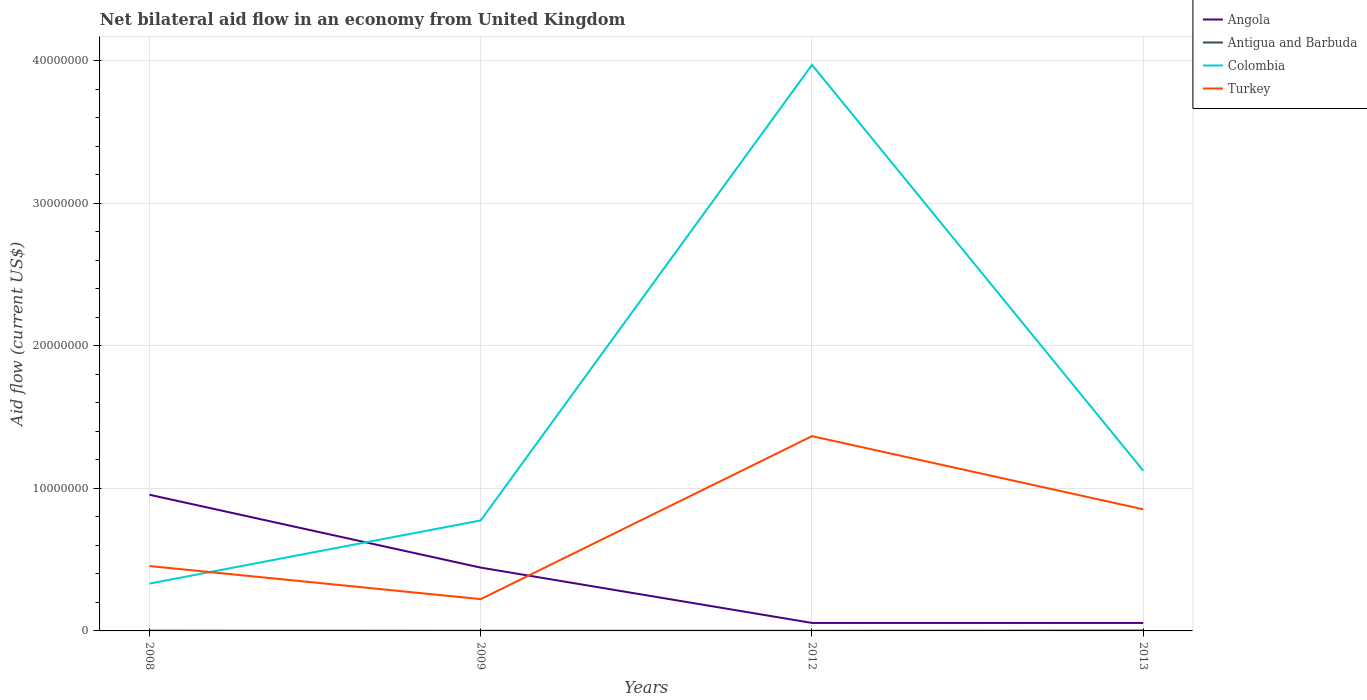In which year was the net bilateral aid flow in Antigua and Barbuda maximum?
Your answer should be very brief. 2009. What is the total net bilateral aid flow in Colombia in the graph?
Offer a terse response. -3.64e+07. What is the difference between the highest and the second highest net bilateral aid flow in Turkey?
Your response must be concise. 1.14e+07. How many lines are there?
Offer a very short reply. 4. How many years are there in the graph?
Provide a short and direct response. 4. What is the difference between two consecutive major ticks on the Y-axis?
Provide a short and direct response. 1.00e+07. Are the values on the major ticks of Y-axis written in scientific E-notation?
Offer a very short reply. No. Does the graph contain grids?
Keep it short and to the point. Yes. How are the legend labels stacked?
Offer a terse response. Vertical. What is the title of the graph?
Offer a terse response. Net bilateral aid flow in an economy from United Kingdom. Does "Djibouti" appear as one of the legend labels in the graph?
Give a very brief answer. No. What is the Aid flow (current US$) in Angola in 2008?
Your answer should be very brief. 9.55e+06. What is the Aid flow (current US$) in Antigua and Barbuda in 2008?
Ensure brevity in your answer.  2.00e+04. What is the Aid flow (current US$) in Colombia in 2008?
Your answer should be compact. 3.32e+06. What is the Aid flow (current US$) in Turkey in 2008?
Provide a succinct answer. 4.55e+06. What is the Aid flow (current US$) in Angola in 2009?
Provide a succinct answer. 4.44e+06. What is the Aid flow (current US$) in Antigua and Barbuda in 2009?
Make the answer very short. 10000. What is the Aid flow (current US$) in Colombia in 2009?
Provide a succinct answer. 7.75e+06. What is the Aid flow (current US$) of Turkey in 2009?
Your answer should be very brief. 2.23e+06. What is the Aid flow (current US$) in Angola in 2012?
Provide a succinct answer. 5.60e+05. What is the Aid flow (current US$) in Antigua and Barbuda in 2012?
Keep it short and to the point. 10000. What is the Aid flow (current US$) in Colombia in 2012?
Make the answer very short. 3.97e+07. What is the Aid flow (current US$) in Turkey in 2012?
Provide a succinct answer. 1.37e+07. What is the Aid flow (current US$) in Angola in 2013?
Keep it short and to the point. 5.60e+05. What is the Aid flow (current US$) of Colombia in 2013?
Offer a terse response. 1.12e+07. What is the Aid flow (current US$) in Turkey in 2013?
Provide a short and direct response. 8.53e+06. Across all years, what is the maximum Aid flow (current US$) of Angola?
Provide a short and direct response. 9.55e+06. Across all years, what is the maximum Aid flow (current US$) in Antigua and Barbuda?
Offer a terse response. 3.00e+04. Across all years, what is the maximum Aid flow (current US$) in Colombia?
Ensure brevity in your answer.  3.97e+07. Across all years, what is the maximum Aid flow (current US$) in Turkey?
Offer a terse response. 1.37e+07. Across all years, what is the minimum Aid flow (current US$) of Angola?
Your answer should be compact. 5.60e+05. Across all years, what is the minimum Aid flow (current US$) of Colombia?
Your response must be concise. 3.32e+06. Across all years, what is the minimum Aid flow (current US$) in Turkey?
Your answer should be compact. 2.23e+06. What is the total Aid flow (current US$) of Angola in the graph?
Your answer should be compact. 1.51e+07. What is the total Aid flow (current US$) of Colombia in the graph?
Your answer should be very brief. 6.20e+07. What is the total Aid flow (current US$) of Turkey in the graph?
Ensure brevity in your answer.  2.90e+07. What is the difference between the Aid flow (current US$) in Angola in 2008 and that in 2009?
Keep it short and to the point. 5.11e+06. What is the difference between the Aid flow (current US$) of Antigua and Barbuda in 2008 and that in 2009?
Your response must be concise. 10000. What is the difference between the Aid flow (current US$) of Colombia in 2008 and that in 2009?
Make the answer very short. -4.43e+06. What is the difference between the Aid flow (current US$) in Turkey in 2008 and that in 2009?
Provide a short and direct response. 2.32e+06. What is the difference between the Aid flow (current US$) of Angola in 2008 and that in 2012?
Keep it short and to the point. 8.99e+06. What is the difference between the Aid flow (current US$) in Colombia in 2008 and that in 2012?
Offer a terse response. -3.64e+07. What is the difference between the Aid flow (current US$) of Turkey in 2008 and that in 2012?
Give a very brief answer. -9.11e+06. What is the difference between the Aid flow (current US$) in Angola in 2008 and that in 2013?
Your response must be concise. 8.99e+06. What is the difference between the Aid flow (current US$) in Colombia in 2008 and that in 2013?
Give a very brief answer. -7.92e+06. What is the difference between the Aid flow (current US$) in Turkey in 2008 and that in 2013?
Your answer should be very brief. -3.98e+06. What is the difference between the Aid flow (current US$) of Angola in 2009 and that in 2012?
Provide a short and direct response. 3.88e+06. What is the difference between the Aid flow (current US$) of Colombia in 2009 and that in 2012?
Make the answer very short. -3.20e+07. What is the difference between the Aid flow (current US$) of Turkey in 2009 and that in 2012?
Ensure brevity in your answer.  -1.14e+07. What is the difference between the Aid flow (current US$) of Angola in 2009 and that in 2013?
Your answer should be compact. 3.88e+06. What is the difference between the Aid flow (current US$) in Colombia in 2009 and that in 2013?
Offer a terse response. -3.49e+06. What is the difference between the Aid flow (current US$) of Turkey in 2009 and that in 2013?
Provide a short and direct response. -6.30e+06. What is the difference between the Aid flow (current US$) of Angola in 2012 and that in 2013?
Provide a succinct answer. 0. What is the difference between the Aid flow (current US$) of Antigua and Barbuda in 2012 and that in 2013?
Keep it short and to the point. -2.00e+04. What is the difference between the Aid flow (current US$) in Colombia in 2012 and that in 2013?
Keep it short and to the point. 2.85e+07. What is the difference between the Aid flow (current US$) of Turkey in 2012 and that in 2013?
Your response must be concise. 5.13e+06. What is the difference between the Aid flow (current US$) of Angola in 2008 and the Aid flow (current US$) of Antigua and Barbuda in 2009?
Your answer should be very brief. 9.54e+06. What is the difference between the Aid flow (current US$) in Angola in 2008 and the Aid flow (current US$) in Colombia in 2009?
Offer a very short reply. 1.80e+06. What is the difference between the Aid flow (current US$) of Angola in 2008 and the Aid flow (current US$) of Turkey in 2009?
Keep it short and to the point. 7.32e+06. What is the difference between the Aid flow (current US$) of Antigua and Barbuda in 2008 and the Aid flow (current US$) of Colombia in 2009?
Make the answer very short. -7.73e+06. What is the difference between the Aid flow (current US$) of Antigua and Barbuda in 2008 and the Aid flow (current US$) of Turkey in 2009?
Your answer should be compact. -2.21e+06. What is the difference between the Aid flow (current US$) in Colombia in 2008 and the Aid flow (current US$) in Turkey in 2009?
Your response must be concise. 1.09e+06. What is the difference between the Aid flow (current US$) in Angola in 2008 and the Aid flow (current US$) in Antigua and Barbuda in 2012?
Your response must be concise. 9.54e+06. What is the difference between the Aid flow (current US$) in Angola in 2008 and the Aid flow (current US$) in Colombia in 2012?
Provide a succinct answer. -3.02e+07. What is the difference between the Aid flow (current US$) in Angola in 2008 and the Aid flow (current US$) in Turkey in 2012?
Offer a terse response. -4.11e+06. What is the difference between the Aid flow (current US$) in Antigua and Barbuda in 2008 and the Aid flow (current US$) in Colombia in 2012?
Ensure brevity in your answer.  -3.97e+07. What is the difference between the Aid flow (current US$) of Antigua and Barbuda in 2008 and the Aid flow (current US$) of Turkey in 2012?
Make the answer very short. -1.36e+07. What is the difference between the Aid flow (current US$) in Colombia in 2008 and the Aid flow (current US$) in Turkey in 2012?
Provide a succinct answer. -1.03e+07. What is the difference between the Aid flow (current US$) of Angola in 2008 and the Aid flow (current US$) of Antigua and Barbuda in 2013?
Your response must be concise. 9.52e+06. What is the difference between the Aid flow (current US$) in Angola in 2008 and the Aid flow (current US$) in Colombia in 2013?
Your answer should be compact. -1.69e+06. What is the difference between the Aid flow (current US$) of Angola in 2008 and the Aid flow (current US$) of Turkey in 2013?
Offer a terse response. 1.02e+06. What is the difference between the Aid flow (current US$) in Antigua and Barbuda in 2008 and the Aid flow (current US$) in Colombia in 2013?
Keep it short and to the point. -1.12e+07. What is the difference between the Aid flow (current US$) of Antigua and Barbuda in 2008 and the Aid flow (current US$) of Turkey in 2013?
Your answer should be very brief. -8.51e+06. What is the difference between the Aid flow (current US$) of Colombia in 2008 and the Aid flow (current US$) of Turkey in 2013?
Offer a terse response. -5.21e+06. What is the difference between the Aid flow (current US$) of Angola in 2009 and the Aid flow (current US$) of Antigua and Barbuda in 2012?
Your answer should be compact. 4.43e+06. What is the difference between the Aid flow (current US$) of Angola in 2009 and the Aid flow (current US$) of Colombia in 2012?
Offer a very short reply. -3.53e+07. What is the difference between the Aid flow (current US$) in Angola in 2009 and the Aid flow (current US$) in Turkey in 2012?
Make the answer very short. -9.22e+06. What is the difference between the Aid flow (current US$) of Antigua and Barbuda in 2009 and the Aid flow (current US$) of Colombia in 2012?
Provide a succinct answer. -3.97e+07. What is the difference between the Aid flow (current US$) of Antigua and Barbuda in 2009 and the Aid flow (current US$) of Turkey in 2012?
Provide a succinct answer. -1.36e+07. What is the difference between the Aid flow (current US$) in Colombia in 2009 and the Aid flow (current US$) in Turkey in 2012?
Ensure brevity in your answer.  -5.91e+06. What is the difference between the Aid flow (current US$) of Angola in 2009 and the Aid flow (current US$) of Antigua and Barbuda in 2013?
Offer a very short reply. 4.41e+06. What is the difference between the Aid flow (current US$) in Angola in 2009 and the Aid flow (current US$) in Colombia in 2013?
Make the answer very short. -6.80e+06. What is the difference between the Aid flow (current US$) of Angola in 2009 and the Aid flow (current US$) of Turkey in 2013?
Your answer should be compact. -4.09e+06. What is the difference between the Aid flow (current US$) of Antigua and Barbuda in 2009 and the Aid flow (current US$) of Colombia in 2013?
Provide a succinct answer. -1.12e+07. What is the difference between the Aid flow (current US$) of Antigua and Barbuda in 2009 and the Aid flow (current US$) of Turkey in 2013?
Offer a very short reply. -8.52e+06. What is the difference between the Aid flow (current US$) of Colombia in 2009 and the Aid flow (current US$) of Turkey in 2013?
Your response must be concise. -7.80e+05. What is the difference between the Aid flow (current US$) of Angola in 2012 and the Aid flow (current US$) of Antigua and Barbuda in 2013?
Offer a terse response. 5.30e+05. What is the difference between the Aid flow (current US$) in Angola in 2012 and the Aid flow (current US$) in Colombia in 2013?
Provide a short and direct response. -1.07e+07. What is the difference between the Aid flow (current US$) in Angola in 2012 and the Aid flow (current US$) in Turkey in 2013?
Provide a short and direct response. -7.97e+06. What is the difference between the Aid flow (current US$) in Antigua and Barbuda in 2012 and the Aid flow (current US$) in Colombia in 2013?
Your response must be concise. -1.12e+07. What is the difference between the Aid flow (current US$) of Antigua and Barbuda in 2012 and the Aid flow (current US$) of Turkey in 2013?
Your response must be concise. -8.52e+06. What is the difference between the Aid flow (current US$) in Colombia in 2012 and the Aid flow (current US$) in Turkey in 2013?
Ensure brevity in your answer.  3.12e+07. What is the average Aid flow (current US$) in Angola per year?
Make the answer very short. 3.78e+06. What is the average Aid flow (current US$) in Antigua and Barbuda per year?
Offer a terse response. 1.75e+04. What is the average Aid flow (current US$) of Colombia per year?
Give a very brief answer. 1.55e+07. What is the average Aid flow (current US$) of Turkey per year?
Ensure brevity in your answer.  7.24e+06. In the year 2008, what is the difference between the Aid flow (current US$) of Angola and Aid flow (current US$) of Antigua and Barbuda?
Your response must be concise. 9.53e+06. In the year 2008, what is the difference between the Aid flow (current US$) of Angola and Aid flow (current US$) of Colombia?
Give a very brief answer. 6.23e+06. In the year 2008, what is the difference between the Aid flow (current US$) in Angola and Aid flow (current US$) in Turkey?
Offer a terse response. 5.00e+06. In the year 2008, what is the difference between the Aid flow (current US$) in Antigua and Barbuda and Aid flow (current US$) in Colombia?
Offer a very short reply. -3.30e+06. In the year 2008, what is the difference between the Aid flow (current US$) in Antigua and Barbuda and Aid flow (current US$) in Turkey?
Your response must be concise. -4.53e+06. In the year 2008, what is the difference between the Aid flow (current US$) of Colombia and Aid flow (current US$) of Turkey?
Ensure brevity in your answer.  -1.23e+06. In the year 2009, what is the difference between the Aid flow (current US$) of Angola and Aid flow (current US$) of Antigua and Barbuda?
Offer a very short reply. 4.43e+06. In the year 2009, what is the difference between the Aid flow (current US$) of Angola and Aid flow (current US$) of Colombia?
Ensure brevity in your answer.  -3.31e+06. In the year 2009, what is the difference between the Aid flow (current US$) of Angola and Aid flow (current US$) of Turkey?
Make the answer very short. 2.21e+06. In the year 2009, what is the difference between the Aid flow (current US$) of Antigua and Barbuda and Aid flow (current US$) of Colombia?
Provide a short and direct response. -7.74e+06. In the year 2009, what is the difference between the Aid flow (current US$) in Antigua and Barbuda and Aid flow (current US$) in Turkey?
Offer a very short reply. -2.22e+06. In the year 2009, what is the difference between the Aid flow (current US$) in Colombia and Aid flow (current US$) in Turkey?
Provide a short and direct response. 5.52e+06. In the year 2012, what is the difference between the Aid flow (current US$) in Angola and Aid flow (current US$) in Colombia?
Give a very brief answer. -3.91e+07. In the year 2012, what is the difference between the Aid flow (current US$) of Angola and Aid flow (current US$) of Turkey?
Your response must be concise. -1.31e+07. In the year 2012, what is the difference between the Aid flow (current US$) in Antigua and Barbuda and Aid flow (current US$) in Colombia?
Offer a very short reply. -3.97e+07. In the year 2012, what is the difference between the Aid flow (current US$) in Antigua and Barbuda and Aid flow (current US$) in Turkey?
Make the answer very short. -1.36e+07. In the year 2012, what is the difference between the Aid flow (current US$) in Colombia and Aid flow (current US$) in Turkey?
Your answer should be very brief. 2.60e+07. In the year 2013, what is the difference between the Aid flow (current US$) in Angola and Aid flow (current US$) in Antigua and Barbuda?
Provide a succinct answer. 5.30e+05. In the year 2013, what is the difference between the Aid flow (current US$) in Angola and Aid flow (current US$) in Colombia?
Give a very brief answer. -1.07e+07. In the year 2013, what is the difference between the Aid flow (current US$) in Angola and Aid flow (current US$) in Turkey?
Offer a very short reply. -7.97e+06. In the year 2013, what is the difference between the Aid flow (current US$) in Antigua and Barbuda and Aid flow (current US$) in Colombia?
Offer a very short reply. -1.12e+07. In the year 2013, what is the difference between the Aid flow (current US$) of Antigua and Barbuda and Aid flow (current US$) of Turkey?
Your answer should be compact. -8.50e+06. In the year 2013, what is the difference between the Aid flow (current US$) of Colombia and Aid flow (current US$) of Turkey?
Offer a terse response. 2.71e+06. What is the ratio of the Aid flow (current US$) of Angola in 2008 to that in 2009?
Provide a short and direct response. 2.15. What is the ratio of the Aid flow (current US$) of Colombia in 2008 to that in 2009?
Offer a very short reply. 0.43. What is the ratio of the Aid flow (current US$) of Turkey in 2008 to that in 2009?
Give a very brief answer. 2.04. What is the ratio of the Aid flow (current US$) in Angola in 2008 to that in 2012?
Ensure brevity in your answer.  17.05. What is the ratio of the Aid flow (current US$) in Antigua and Barbuda in 2008 to that in 2012?
Offer a very short reply. 2. What is the ratio of the Aid flow (current US$) of Colombia in 2008 to that in 2012?
Make the answer very short. 0.08. What is the ratio of the Aid flow (current US$) of Turkey in 2008 to that in 2012?
Provide a short and direct response. 0.33. What is the ratio of the Aid flow (current US$) of Angola in 2008 to that in 2013?
Make the answer very short. 17.05. What is the ratio of the Aid flow (current US$) in Colombia in 2008 to that in 2013?
Offer a very short reply. 0.3. What is the ratio of the Aid flow (current US$) in Turkey in 2008 to that in 2013?
Your response must be concise. 0.53. What is the ratio of the Aid flow (current US$) of Angola in 2009 to that in 2012?
Your answer should be very brief. 7.93. What is the ratio of the Aid flow (current US$) in Colombia in 2009 to that in 2012?
Make the answer very short. 0.2. What is the ratio of the Aid flow (current US$) of Turkey in 2009 to that in 2012?
Offer a very short reply. 0.16. What is the ratio of the Aid flow (current US$) of Angola in 2009 to that in 2013?
Offer a very short reply. 7.93. What is the ratio of the Aid flow (current US$) in Antigua and Barbuda in 2009 to that in 2013?
Offer a very short reply. 0.33. What is the ratio of the Aid flow (current US$) of Colombia in 2009 to that in 2013?
Provide a short and direct response. 0.69. What is the ratio of the Aid flow (current US$) in Turkey in 2009 to that in 2013?
Offer a very short reply. 0.26. What is the ratio of the Aid flow (current US$) of Angola in 2012 to that in 2013?
Offer a terse response. 1. What is the ratio of the Aid flow (current US$) in Colombia in 2012 to that in 2013?
Ensure brevity in your answer.  3.53. What is the ratio of the Aid flow (current US$) of Turkey in 2012 to that in 2013?
Provide a succinct answer. 1.6. What is the difference between the highest and the second highest Aid flow (current US$) in Angola?
Provide a succinct answer. 5.11e+06. What is the difference between the highest and the second highest Aid flow (current US$) of Colombia?
Offer a very short reply. 2.85e+07. What is the difference between the highest and the second highest Aid flow (current US$) of Turkey?
Make the answer very short. 5.13e+06. What is the difference between the highest and the lowest Aid flow (current US$) in Angola?
Offer a very short reply. 8.99e+06. What is the difference between the highest and the lowest Aid flow (current US$) in Colombia?
Provide a short and direct response. 3.64e+07. What is the difference between the highest and the lowest Aid flow (current US$) in Turkey?
Offer a terse response. 1.14e+07. 